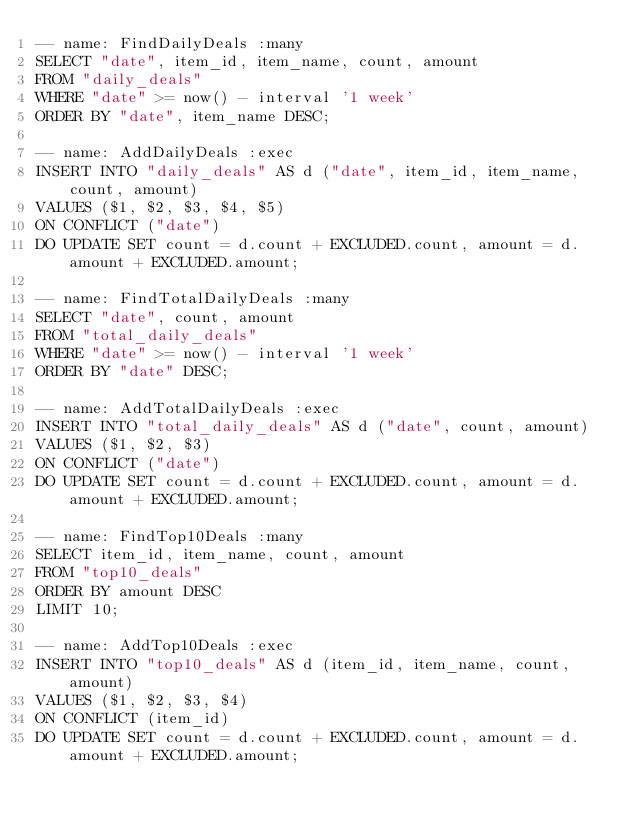<code> <loc_0><loc_0><loc_500><loc_500><_SQL_>-- name: FindDailyDeals :many
SELECT "date", item_id, item_name, count, amount
FROM "daily_deals"
WHERE "date" >= now() - interval '1 week'
ORDER BY "date", item_name DESC;

-- name: AddDailyDeals :exec
INSERT INTO "daily_deals" AS d ("date", item_id, item_name, count, amount)
VALUES ($1, $2, $3, $4, $5)
ON CONFLICT ("date")
DO UPDATE SET count = d.count + EXCLUDED.count, amount = d.amount + EXCLUDED.amount;

-- name: FindTotalDailyDeals :many
SELECT "date", count, amount
FROM "total_daily_deals"
WHERE "date" >= now() - interval '1 week'
ORDER BY "date" DESC;

-- name: AddTotalDailyDeals :exec
INSERT INTO "total_daily_deals" AS d ("date", count, amount)
VALUES ($1, $2, $3)
ON CONFLICT ("date")
DO UPDATE SET count = d.count + EXCLUDED.count, amount = d.amount + EXCLUDED.amount;

-- name: FindTop10Deals :many
SELECT item_id, item_name, count, amount
FROM "top10_deals"
ORDER BY amount DESC
LIMIT 10;

-- name: AddTop10Deals :exec
INSERT INTO "top10_deals" AS d (item_id, item_name, count, amount)
VALUES ($1, $2, $3, $4)
ON CONFLICT (item_id)
DO UPDATE SET count = d.count + EXCLUDED.count, amount = d.amount + EXCLUDED.amount;
</code> 